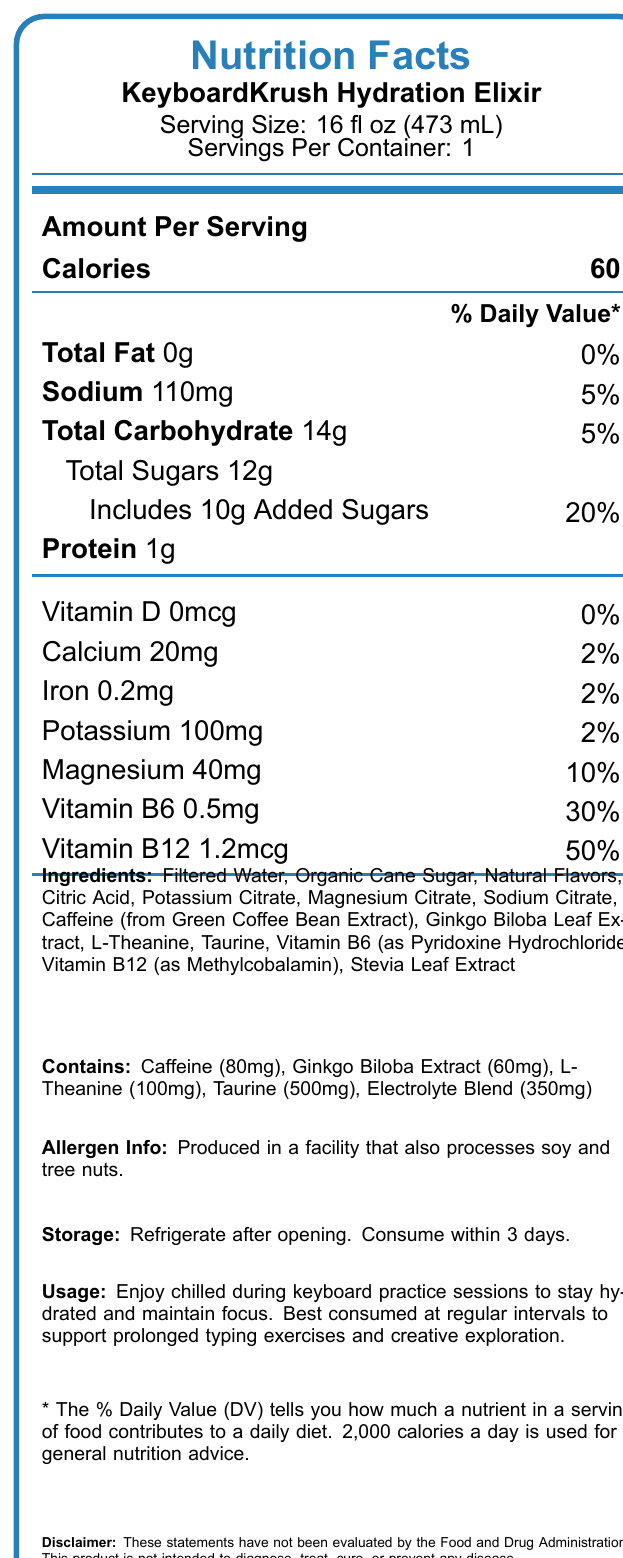what is the serving size of the beverage? The document states that the serving size of the KeyboardKrush Hydration Elixir is 16 fl oz (473 mL).
Answer: 16 fl oz (473 mL) how many calories are in one serving? The document specifies that there are 60 calories per serving.
Answer: 60 what is the sodium content per serving? The sodium content listed in the document is 110mg per serving.
Answer: 110mg how much added sugar is in a serving? The document indicates that there are 10g of added sugars in each serving.
Answer: 10g what is the percentage daily value of vitamin B12 per serving? The document states that the percentage daily value of vitamin B12 is 50%.
Answer: 50% which ingredient in the beverage is a source of caffeine? A. Green Tea Extract B. Green Coffee Bean Extract C. Guarana Seed Extract D. Black Tea Extract E. Yerba Mate Extract The document lists caffeine from Green Coffee Bean Extract as an ingredient.
Answer: B. Green Coffee Bean Extract what is the protein content in a serving of KeyboardKrush Hydration Elixir? A. 0g B. 0.5g C. 1g D. 2g E. 3g The document states that there is 1g of protein per serving.
Answer: C. 1g does the beverage contain tree nuts? The document mentions that the product is produced in a facility that processes soy and tree nuts but does not indicate that tree nuts are part of the ingredients.
Answer: No describe the main idea of this document. The overall purpose of the document is to inform consumers about the nutritional facts, ingredients, and benefits of the KeyboardKrush Hydration Elixir, as well as how to store and use it properly.
Answer: The document provides detailed nutrition information about KeyboardKrush Hydration Elixir, a hydrating beverage designed to improve focus and reduce hand fatigue during keyboard practice. It lists serving size, calories, various nutrient contents, ingredients, allergen info, storage instructions, usage suggestions, and product claims. what is the total carbohydrate content per serving? According to the document, the total carbohydrate content per serving is 14g.
Answer: 14g how much caffeine does the beverage contain? The document lists 80mg of caffeine per serving of the beverage.
Answer: 80mg what electrolyte blend is included in this beverage? The nutrition facts indicate that the beverage contains a 350mg electrolyte blend.
Answer: 350mg how should the beverage be stored after opening? The document advises refrigerating the beverage after opening and consuming it within 3 days.
Answer: Refrigerate after opening. Consume within 3 days. where is the caffeine in the beverage derived from? The document specifies that the caffeine in the beverage comes from Green Coffee Bean Extract.
Answer: Green Coffee Bean Extract is there any iron in the beverage? The document indicates that there is 0.2mg of iron per serving, which amounts to 2% of the daily value.
Answer: Yes can this document confirm the beverage will improve keyboard performance? While the document makes claims such as "Supports mental clarity and focus" and "Helps reduce hand fatigue," it also includes a disclaimer stating that these statements have not been evaluated by the Food and Drug Administration. Therefore, it can't be conclusively determined from the document alone.
Answer: No 